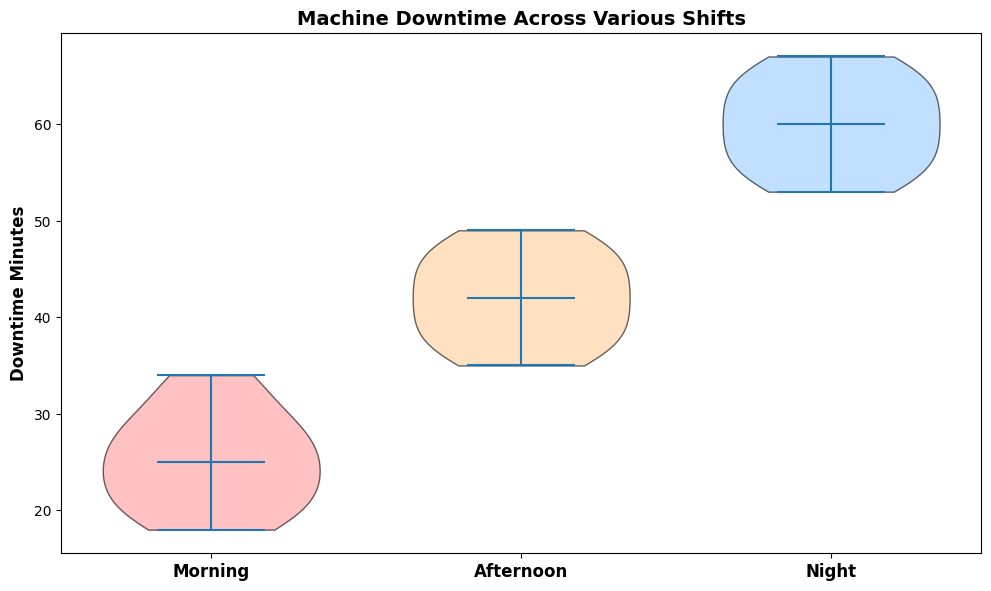What are the median values for machine downtime across Morning, Afternoon, and Night shifts? The figure's violin plot shows the median values represented as a line within each violin. For Morning, the median appears to be 25 minutes, for Afternoon it's 41 minutes, and for Night it's 60 minutes.
Answer: 25, 41, 60 Which shift has the highest variability in machine downtime? Variability can be observed by the width and spread of the violin plot. The Night shift has the most considerable spread, indicating the highest variability in machine downtime.
Answer: Night Is the median downtime for the Night shift higher than that of the Afternoon shift? The median for the Night shift is visually higher than that of the Afternoon shift as the line inside the violin plot for the Night shift is positioned higher than the line inside the Afternoon shift's plot.
Answer: Yes How does the median morning shift downtime compare with the median afternoon shift downtime? The Morning shift median is 25 minutes, while the Afternoon shift median is 41 minutes. Hence, the Afternoon shift median is higher by 16 minutes.
Answer: The Afternoon shift median is higher by 16 minutes What is the range of machine downtime for the Afternoon shift? The spread of the violin plot for the Afternoon shift indicates that the lowest downtime is around 35 minutes and the highest is around 49 minutes, so the range is 49 - 35 = 14 minutes.
Answer: 14 minutes Between which two shifts is the difference in median downtime the greatest? The medians for Morning, Afternoon, and Night shifts are 25, 41, and 60 minutes, respectively. The differences are 60 - 41 = 19 minutes and 41 - 25 = 16 minutes. Thus, the greatest difference in medians is between the Night and Afternoon shifts.
Answer: Night and Afternoon Which violin plot has the largest number of data points, and how can you tell? Each shift has the same number of points since all violin plots appear to be identical in width and symmetry, suggesting equal sample sizes for Morning, Afternoon, and Night shifts.
Answer: All shifts have an equal number of data points What is the minimum machine downtime for the Morning shift? The bottom edge of the Morning shift's violin plot indicates the minimum downtime, which appears to be around 18 minutes.
Answer: 18 minutes In which shift could you consider the machine to be the most reliable in terms of less downtime? Considering less downtime and variability, the Morning shift's violin plot is both centered at a lower downtime value and less spread out, indicating more reliability.
Answer: Morning 